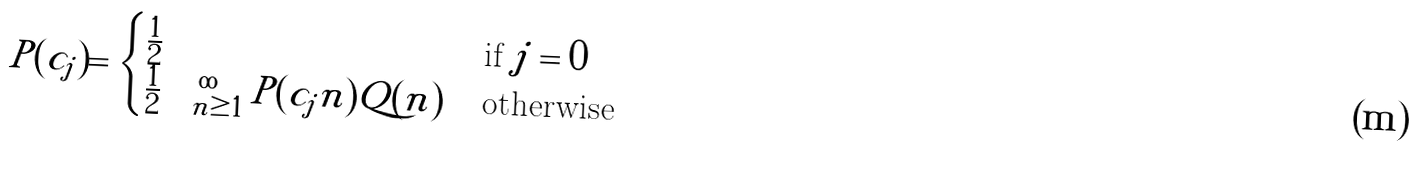<formula> <loc_0><loc_0><loc_500><loc_500>P ( c _ { j } ) = \begin{cases} \frac { 1 } { 2 } & \text {if} \ j = 0 \\ \frac { 1 } { 2 } \sum _ { n \geq 1 } ^ { \infty } P ( c _ { j } | n ) Q ( n ) & \text {otherwise} \end{cases}</formula> 